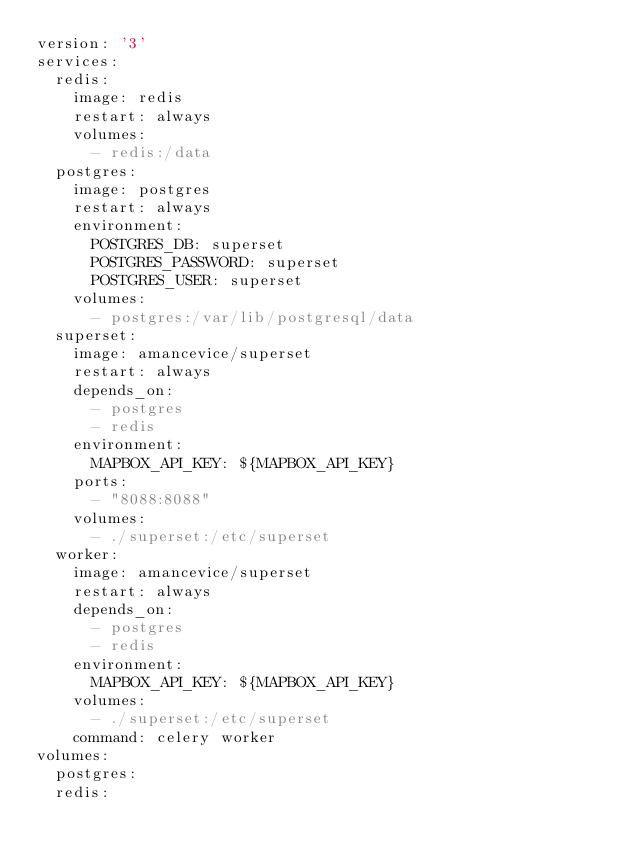<code> <loc_0><loc_0><loc_500><loc_500><_YAML_>version: '3'
services:
  redis:
    image: redis
    restart: always
    volumes:
      - redis:/data
  postgres:
    image: postgres
    restart: always
    environment:
      POSTGRES_DB: superset
      POSTGRES_PASSWORD: superset
      POSTGRES_USER: superset
    volumes:
      - postgres:/var/lib/postgresql/data
  superset:
    image: amancevice/superset
    restart: always
    depends_on:
      - postgres
      - redis
    environment:
      MAPBOX_API_KEY: ${MAPBOX_API_KEY}
    ports:
      - "8088:8088"
    volumes:
      - ./superset:/etc/superset
  worker:
    image: amancevice/superset
    restart: always
    depends_on:
      - postgres
      - redis
    environment:
      MAPBOX_API_KEY: ${MAPBOX_API_KEY}
    volumes:
      - ./superset:/etc/superset
    command: celery worker
volumes:
  postgres:
  redis:
</code> 